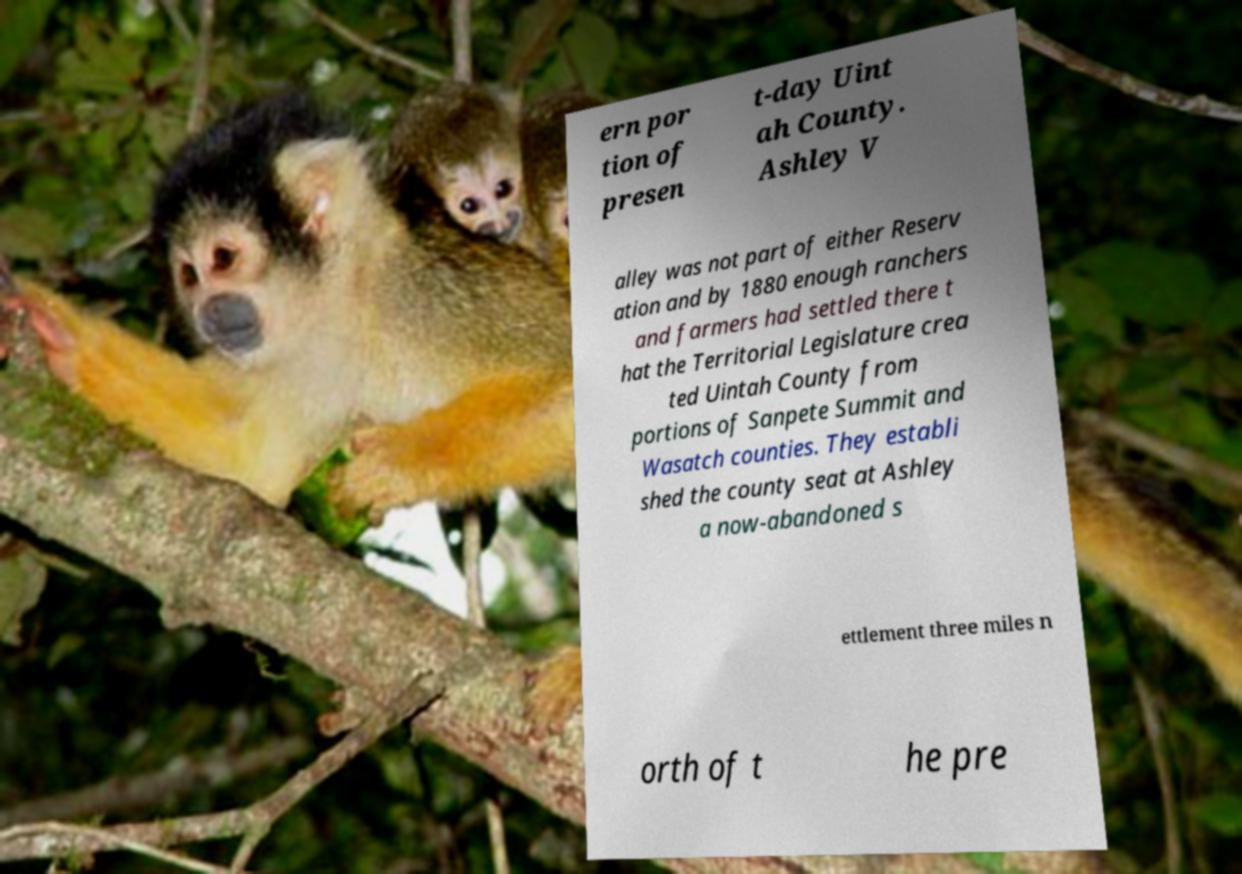Can you accurately transcribe the text from the provided image for me? ern por tion of presen t-day Uint ah County. Ashley V alley was not part of either Reserv ation and by 1880 enough ranchers and farmers had settled there t hat the Territorial Legislature crea ted Uintah County from portions of Sanpete Summit and Wasatch counties. They establi shed the county seat at Ashley a now-abandoned s ettlement three miles n orth of t he pre 